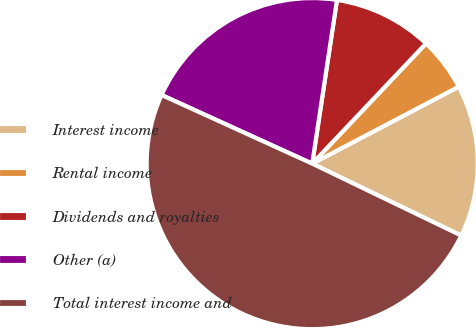<chart> <loc_0><loc_0><loc_500><loc_500><pie_chart><fcel>Interest income<fcel>Rental income<fcel>Dividends and royalties<fcel>Other (a)<fcel>Total interest income and<nl><fcel>14.85%<fcel>5.24%<fcel>9.68%<fcel>20.59%<fcel>49.65%<nl></chart> 